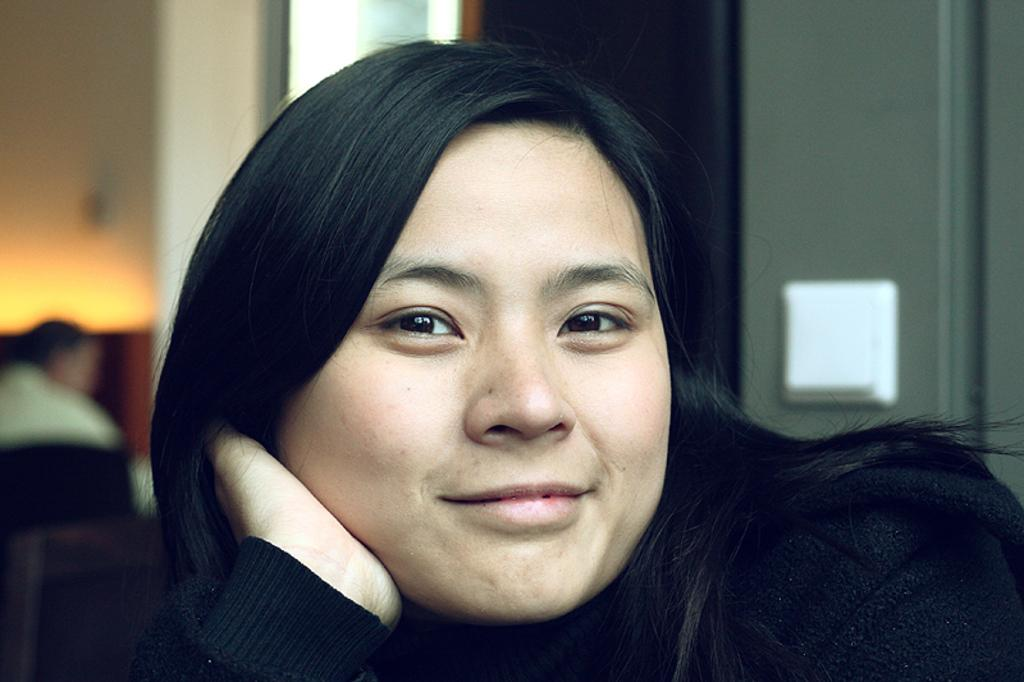What is the woman in the image doing? The woman is smiling in the image. What is the woman wearing in the image? The woman is wearing a black sweater in the image. What can be found on the wall in the image? There is an electric switch on the wall in the image. How far away is the summer season from the image? The concept of "summer season" is not present in the image, so it cannot be determined how far away it is. 